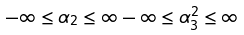Convert formula to latex. <formula><loc_0><loc_0><loc_500><loc_500>- \infty \leq \alpha _ { 2 } \leq \infty \, - \infty \leq \alpha ^ { 2 } _ { 3 } \leq \infty</formula> 